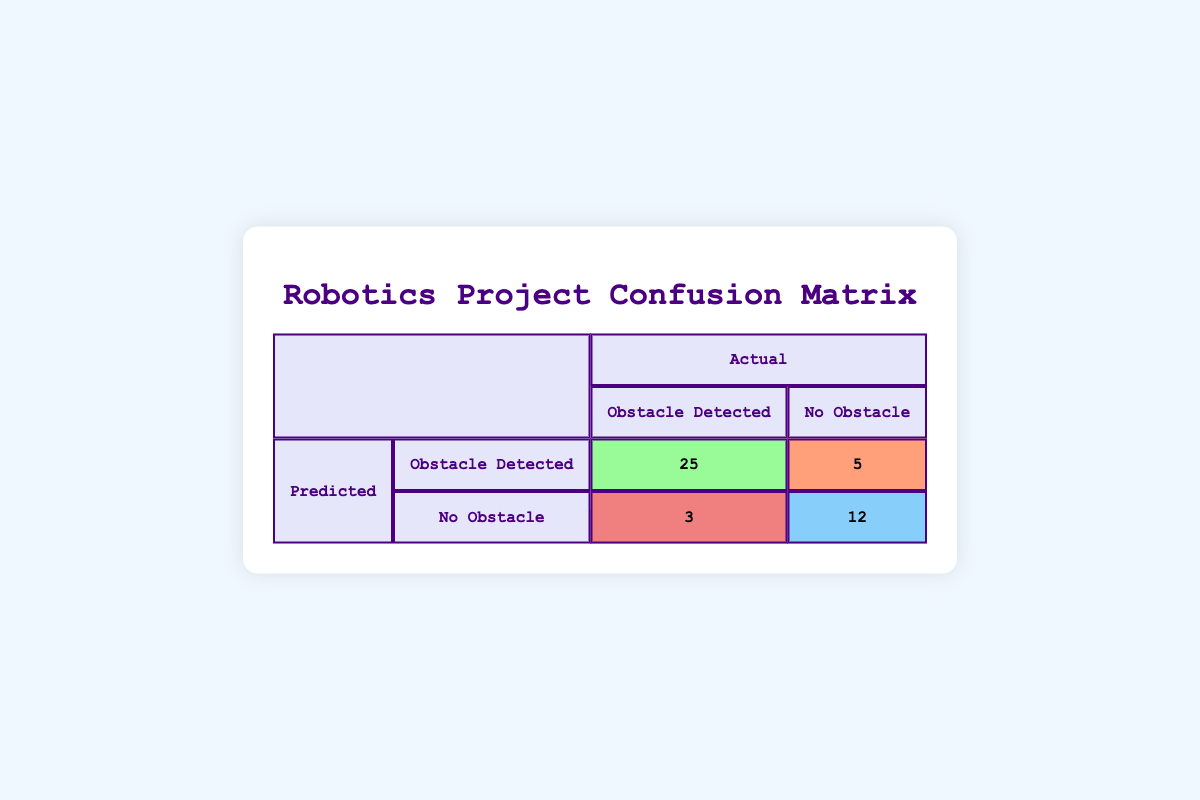What is the count of true positives? The count of true positives is directly given in the summary, which indicates the number of instances where the predicted outcome of "Obstacle Detected" matches the actual outcome. This value is 25.
Answer: 25 What is the total number of actual obstacles detected? The total number of actual obstacles detected can be found by summing the true positives and false negatives from the summary. True positives (25) + False negatives (3) = 28.
Answer: 28 Did Robot D correctly predict the absence of an obstacle? By examining the cell for Robot D, the predicted outcome is "No Obstacle" and the actual outcome is also "No Obstacle." Since these match, the answer is yes.
Answer: Yes What is the false positive rate? The false positive rate is calculated by dividing the false positives by the sum of false positives and true negatives. False positives (5) + True negatives (12) = 17, so the rate is 5/17, which is approximately 0.294.
Answer: Approximately 0.294 What is the difference in the count of predicted obstacles between Robot A and Robot C? Robot A has a count of 25 predicted obstacles (true positives) and Robot C has a count of 0 predicted obstacles (false negatives). The difference is 25 - 0 = 25.
Answer: 25 What is the total number of predictions made? The total predictions can be calculated by adding all the counts from the confusion matrix: 25 (true positive) + 5 (false positive) + 3 (false negative) + 12 (true negative) = 45.
Answer: 45 Was the performance of Robot B better than Robot C in detecting obstacles? Robot B predicted "Obstacle Detected" when there were none (5 false positives). Robot C incorrectly predicted "No Obstacle" when there was one (3 false negatives). Since Robot B had more incorrect predictions compared to Robot C, the performance is not better.
Answer: No How many total instances did Robot A correctly identify? Robot A's performance includes true positives where it detected obstacles correctly. The total instances it identified correctly is equal to its true positive count, which is 25.
Answer: 25 What fraction of the total predictions made were true negatives? The fraction is calculated by taking the true negatives (12) and dividing by the total predictions (45). Thus, the fraction is 12/45, which simplifies to 4/15, or approximately 0.267.
Answer: Approximately 0.267 